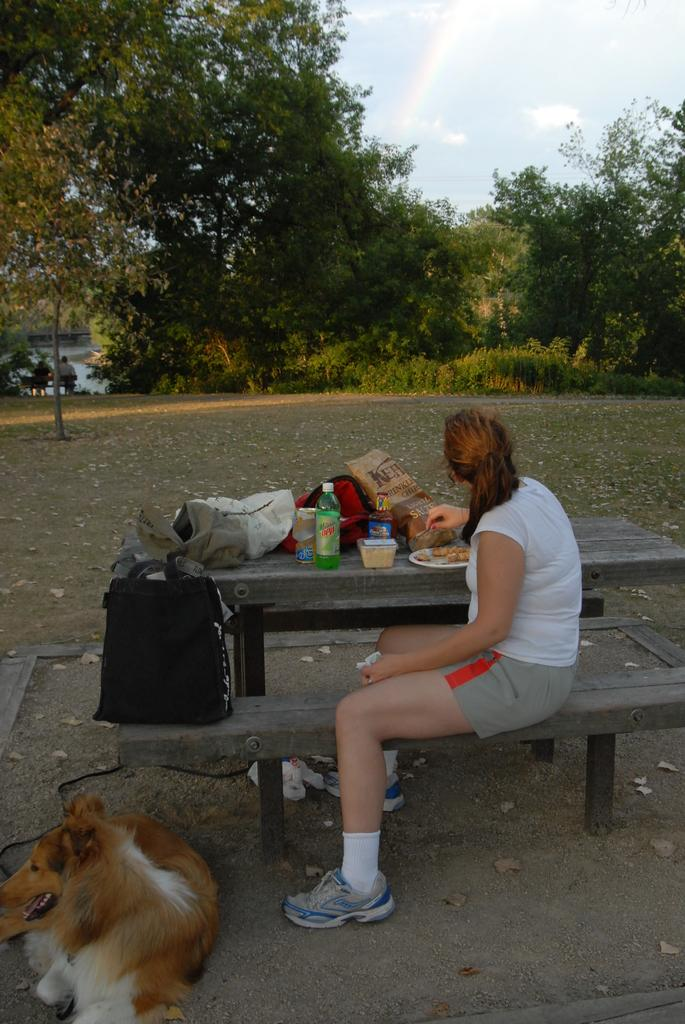What is the person in the image doing? The person is sitting on a bench. What objects are on the table in the image? There is a bottle, a plate, food, and a bag on the table. What can be seen in the background of the image? There are trees in the background. What animal is present in the image? A dog is sitting in front of the table. What type of instrument is the person playing in the image? There is no instrument present in the image; the person is simply sitting on a bench. 